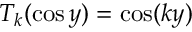Convert formula to latex. <formula><loc_0><loc_0><loc_500><loc_500>T _ { k } ( \cos y ) = \cos ( k y )</formula> 